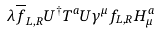<formula> <loc_0><loc_0><loc_500><loc_500>\lambda \overline { f } _ { L , R } U ^ { \dagger } T ^ { a } U \gamma ^ { \mu } f _ { L , R } H ^ { a } _ { \mu }</formula> 